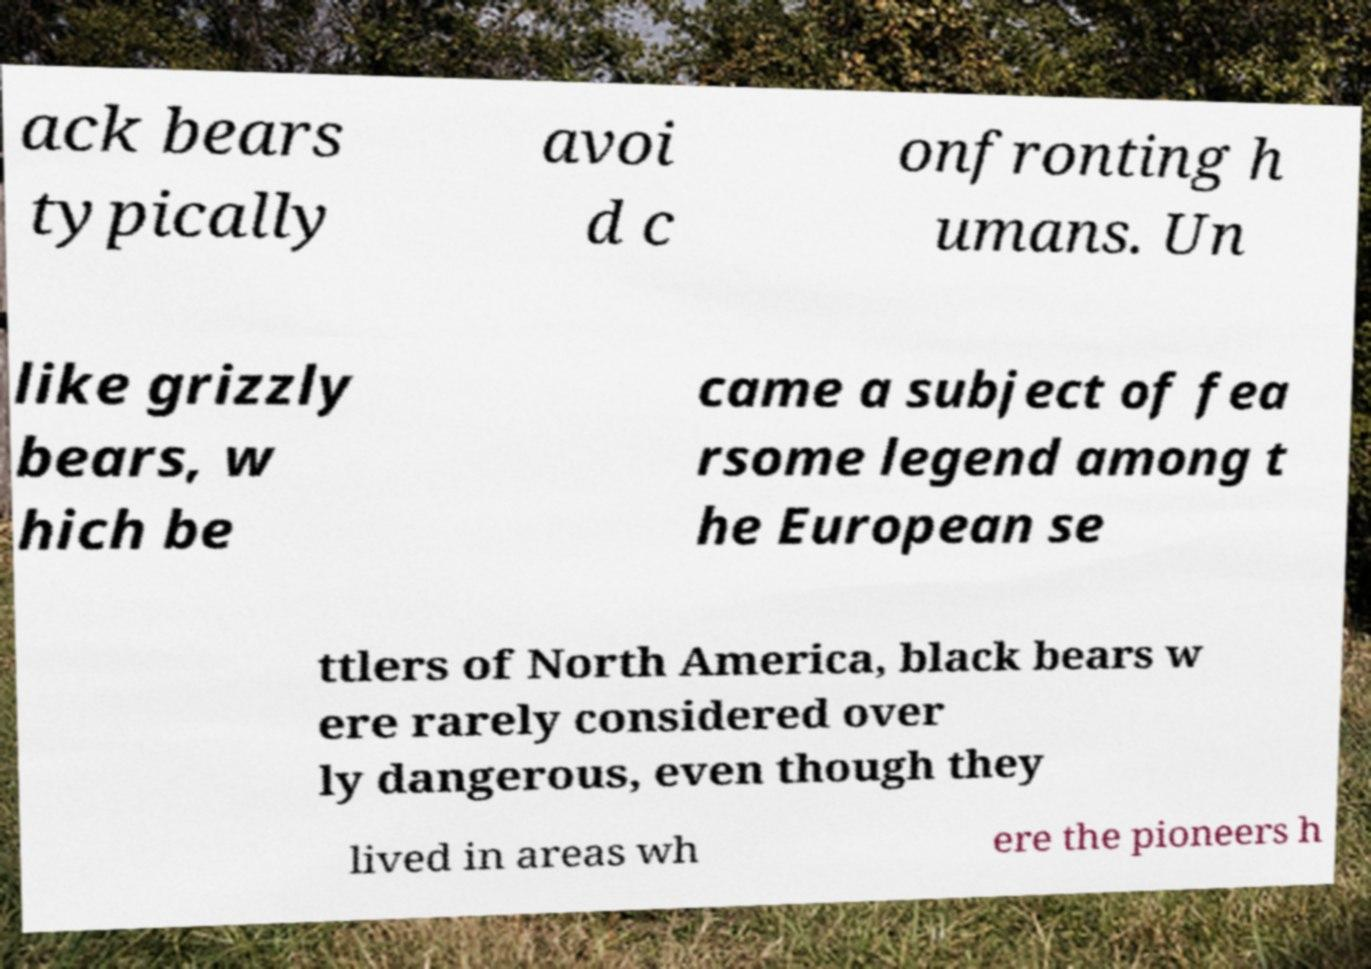Could you assist in decoding the text presented in this image and type it out clearly? ack bears typically avoi d c onfronting h umans. Un like grizzly bears, w hich be came a subject of fea rsome legend among t he European se ttlers of North America, black bears w ere rarely considered over ly dangerous, even though they lived in areas wh ere the pioneers h 